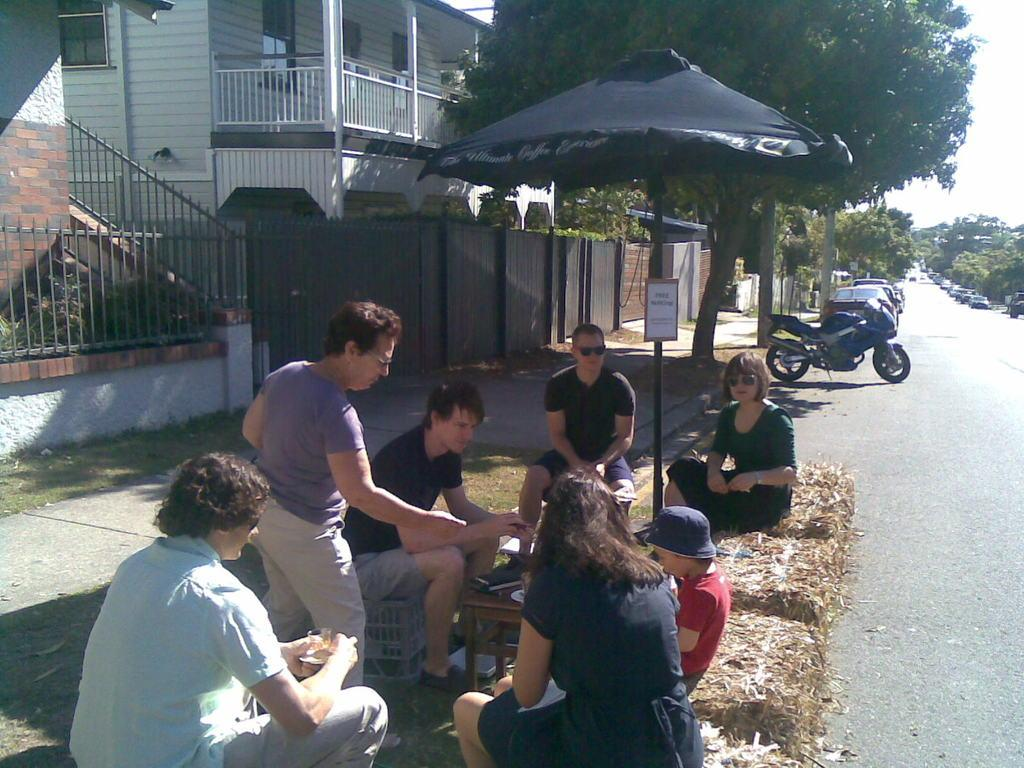What are the people in the image doing? There is a group of people sitting under an umbrella in the image. What color is the umbrella? The umbrella is black in color. What can be seen on the right side of the image? There is a bike parked on the right side of the image. Where is the bike located? The bike is on the road. What is present on the left side of the image? There are trees and buildings on the left side of the image. How many elements are on the left side of the image? There are two elements on the left side of the image: trees and buildings. Can you see the brain of one of the people sitting under the umbrella in the image? There is no indication of anyone's brain being visible in the image; it only shows a group of people sitting under an umbrella. Is there a spark coming from the bike in the image? There is no spark visible in the image; it only shows a bike parked on the road. 